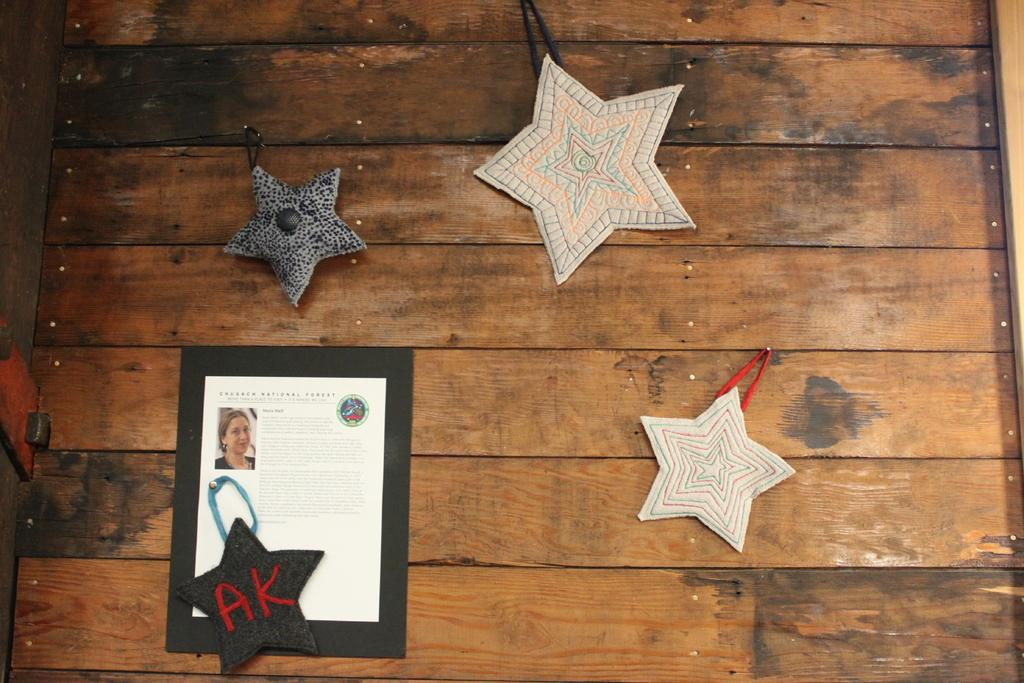What is on the wooden board in the image? There are crafts on a wooden board in the image. What else can be seen on the wooden board? There is a frame on the wooden board in the image. What is located on the left side of the image? There are unspecified objects on the left side of the image. What is the topic of the discussion taking place in the image? There is no discussion taking place in the image; it features crafts, a frame, and unspecified objects. Can you see a cat in the image? There is no cat present in the image. 